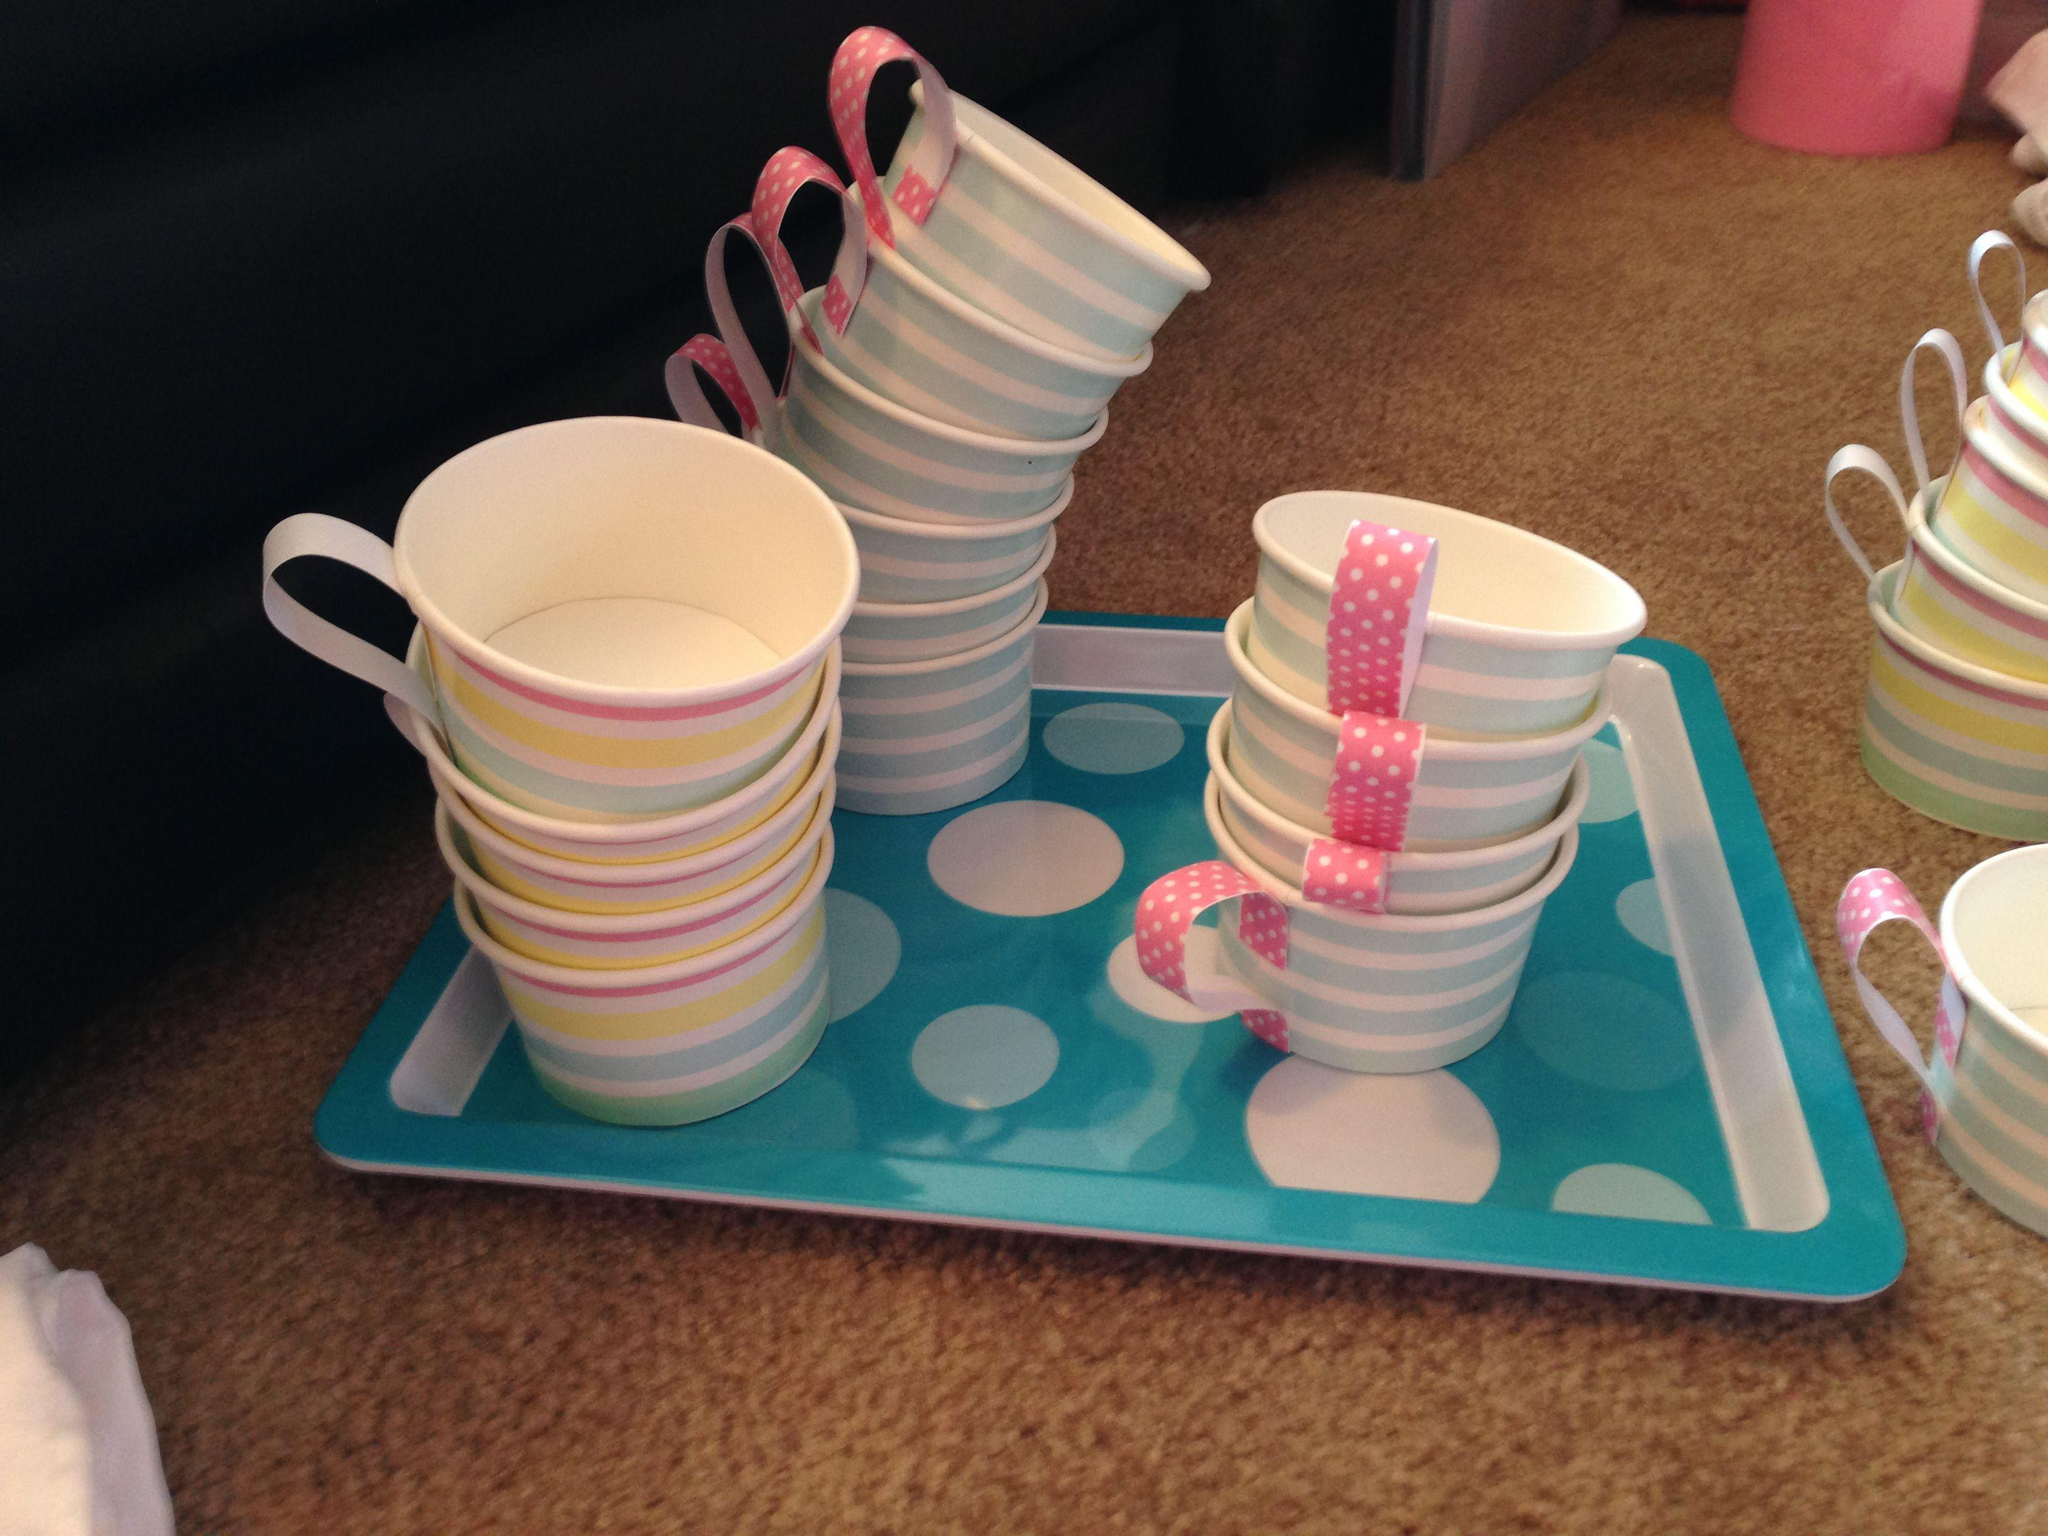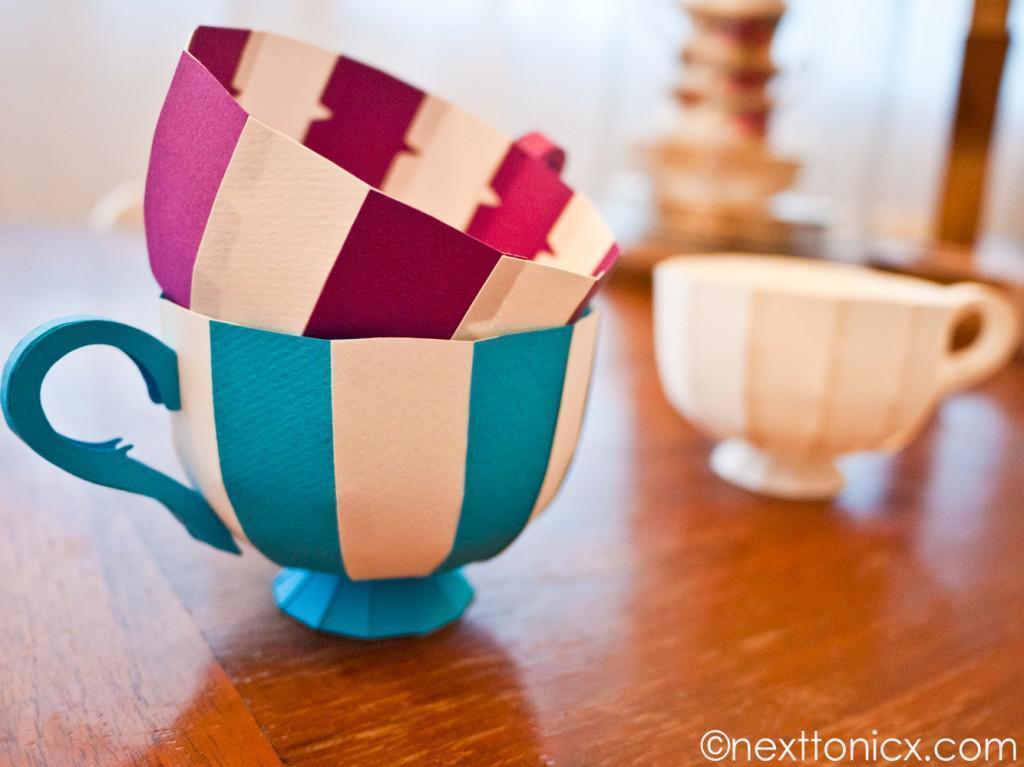The first image is the image on the left, the second image is the image on the right. Evaluate the accuracy of this statement regarding the images: "An image shows at least two stacks of at least three cups on matching saucers, featuring different solid colors, polka dots, and scalloped edges.". Is it true? Answer yes or no. No. 